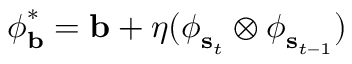Convert formula to latex. <formula><loc_0><loc_0><loc_500><loc_500>\begin{array} { r } { \phi _ { b } ^ { * } = b + \eta ( \phi _ { s _ { t } } \otimes \phi _ { s _ { t - 1 } } ) } \end{array}</formula> 